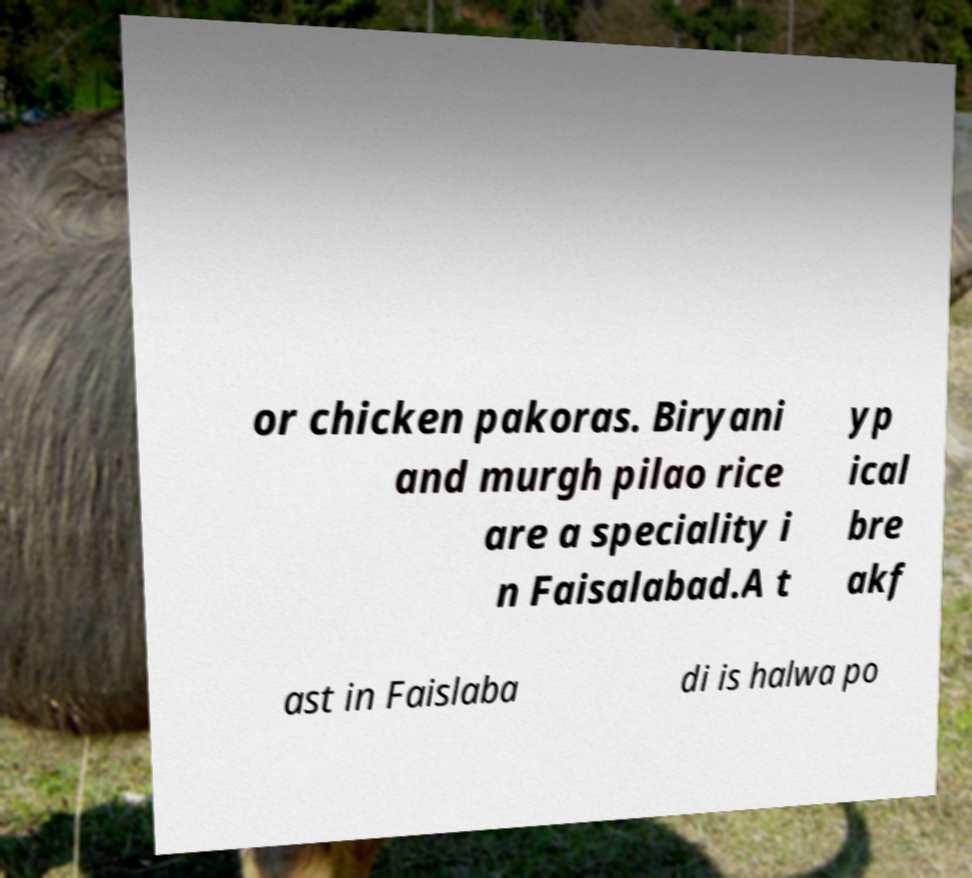There's text embedded in this image that I need extracted. Can you transcribe it verbatim? or chicken pakoras. Biryani and murgh pilao rice are a speciality i n Faisalabad.A t yp ical bre akf ast in Faislaba di is halwa po 